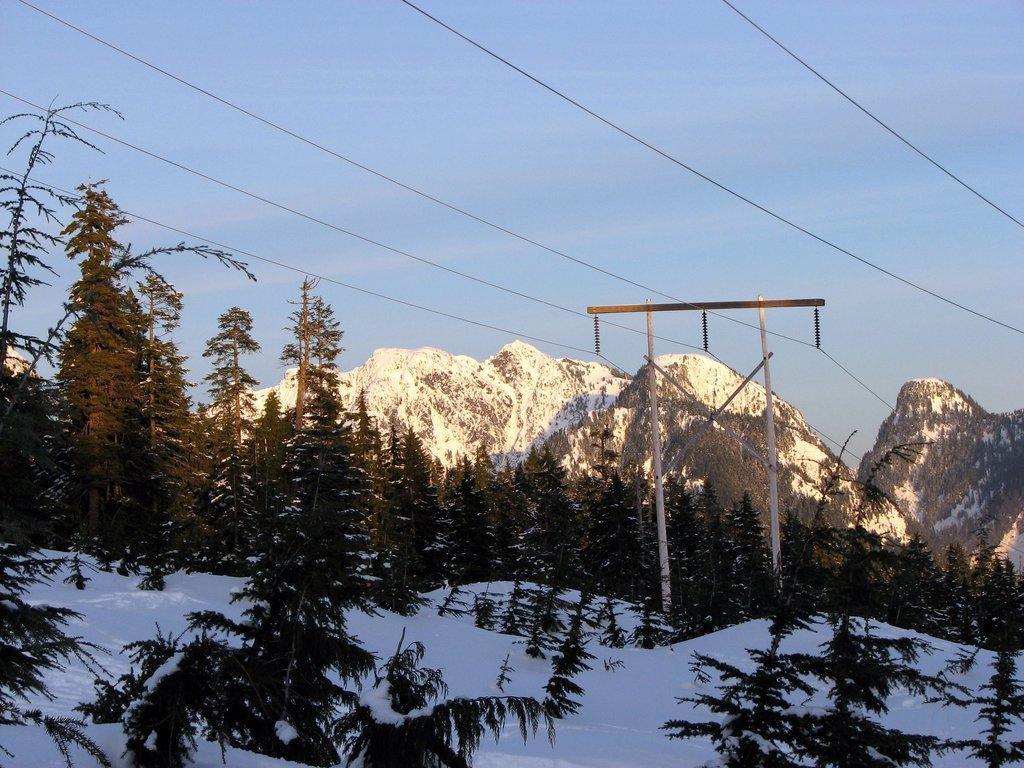Can you describe this image briefly? In this image I can see trees in green color, snow in white color. Background I can see mountains and the sky is in blue color. 